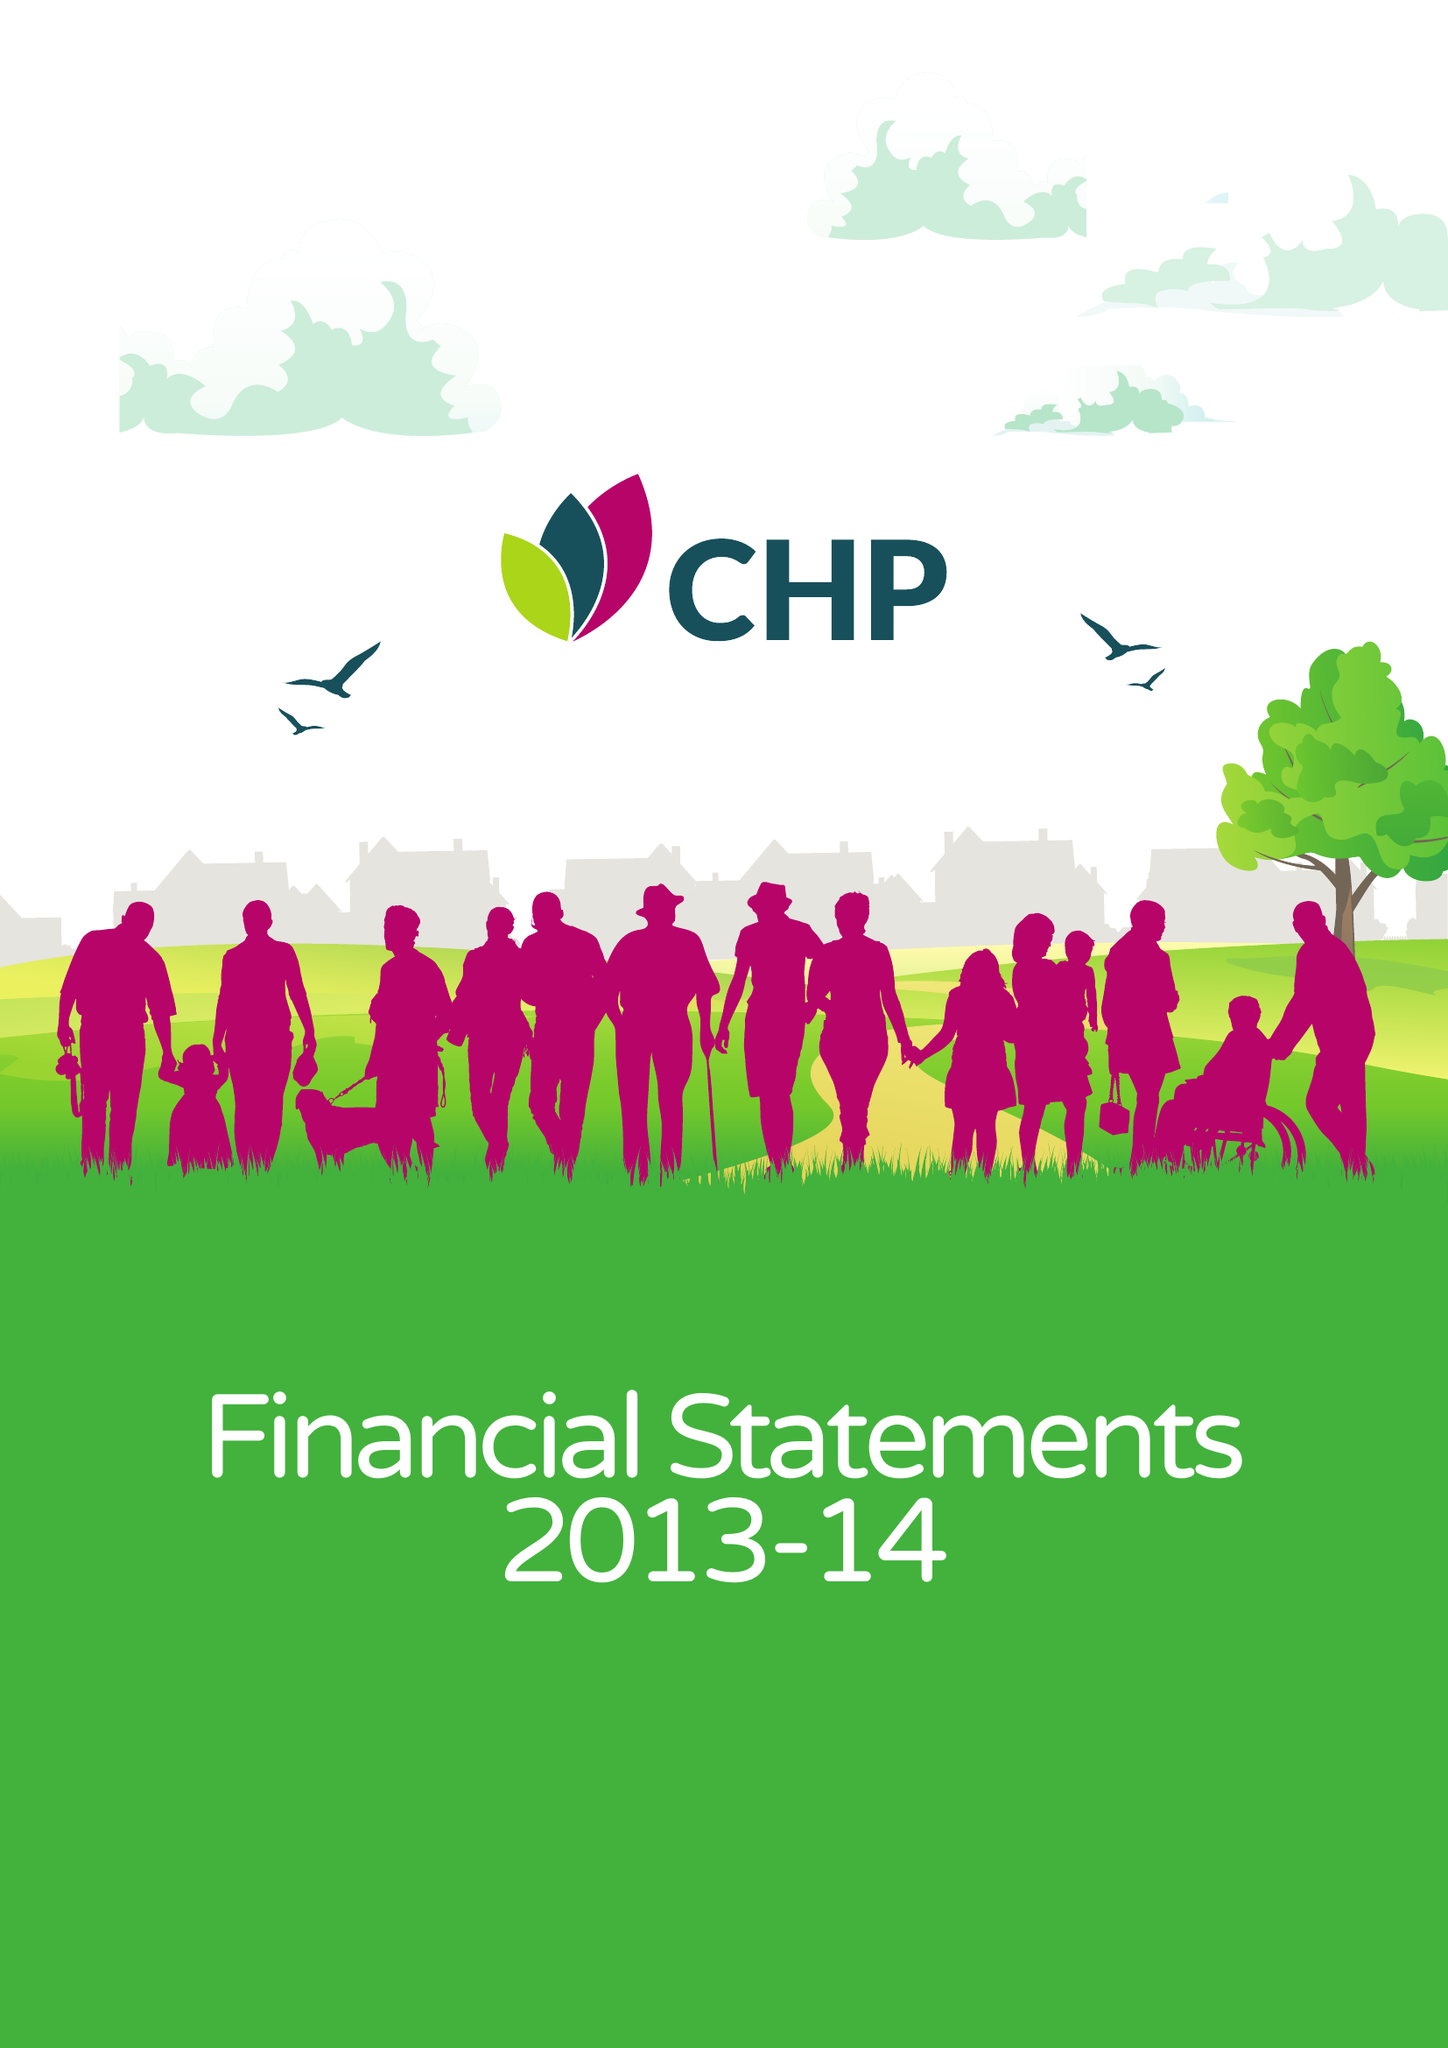What is the value for the report_date?
Answer the question using a single word or phrase. 2014-03-31 